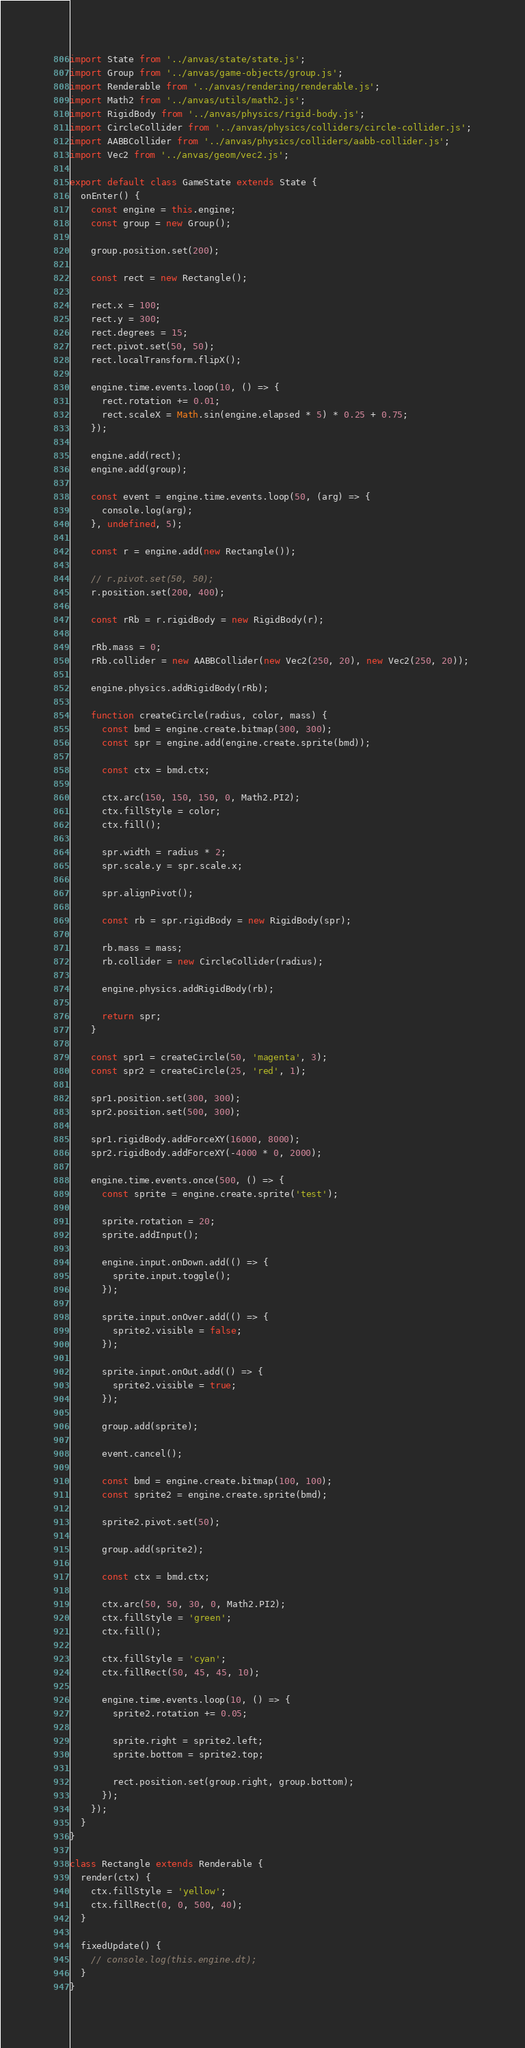<code> <loc_0><loc_0><loc_500><loc_500><_JavaScript_>import State from '../anvas/state/state.js';
import Group from '../anvas/game-objects/group.js';
import Renderable from '../anvas/rendering/renderable.js';
import Math2 from '../anvas/utils/math2.js';
import RigidBody from '../anvas/physics/rigid-body.js';
import CircleCollider from '../anvas/physics/colliders/circle-collider.js';
import AABBCollider from '../anvas/physics/colliders/aabb-collider.js';
import Vec2 from '../anvas/geom/vec2.js';

export default class GameState extends State {
  onEnter() {
    const engine = this.engine;
    const group = new Group();

    group.position.set(200);

    const rect = new Rectangle();

    rect.x = 100;
    rect.y = 300;
    rect.degrees = 15;
    rect.pivot.set(50, 50);
    rect.localTransform.flipX();

    engine.time.events.loop(10, () => {
      rect.rotation += 0.01;
      rect.scaleX = Math.sin(engine.elapsed * 5) * 0.25 + 0.75;
    });

    engine.add(rect);
    engine.add(group);

    const event = engine.time.events.loop(50, (arg) => {
      console.log(arg);
    }, undefined, 5);

    const r = engine.add(new Rectangle());

    // r.pivot.set(50, 50);
    r.position.set(200, 400);

    const rRb = r.rigidBody = new RigidBody(r);

    rRb.mass = 0;
    rRb.collider = new AABBCollider(new Vec2(250, 20), new Vec2(250, 20));

    engine.physics.addRigidBody(rRb);

    function createCircle(radius, color, mass) {
      const bmd = engine.create.bitmap(300, 300);
      const spr = engine.add(engine.create.sprite(bmd));

      const ctx = bmd.ctx;

      ctx.arc(150, 150, 150, 0, Math2.PI2);
      ctx.fillStyle = color;
      ctx.fill();

      spr.width = radius * 2;
      spr.scale.y = spr.scale.x;

      spr.alignPivot();

      const rb = spr.rigidBody = new RigidBody(spr);

      rb.mass = mass;
      rb.collider = new CircleCollider(radius);

      engine.physics.addRigidBody(rb);

      return spr;
    }

    const spr1 = createCircle(50, 'magenta', 3);
    const spr2 = createCircle(25, 'red', 1);

    spr1.position.set(300, 300);
    spr2.position.set(500, 300);

    spr1.rigidBody.addForceXY(16000, 8000);
    spr2.rigidBody.addForceXY(-4000 * 0, 2000);

    engine.time.events.once(500, () => {
      const sprite = engine.create.sprite('test');

      sprite.rotation = 20;
      sprite.addInput();

      engine.input.onDown.add(() => {
        sprite.input.toggle();
      });

      sprite.input.onOver.add(() => {
        sprite2.visible = false;    
      });

      sprite.input.onOut.add(() => {
        sprite2.visible = true;    
      });

      group.add(sprite);

      event.cancel();

      const bmd = engine.create.bitmap(100, 100);
      const sprite2 = engine.create.sprite(bmd);

      sprite2.pivot.set(50);

      group.add(sprite2);

      const ctx = bmd.ctx;

      ctx.arc(50, 50, 30, 0, Math2.PI2);
      ctx.fillStyle = 'green';
      ctx.fill();

      ctx.fillStyle = 'cyan';
      ctx.fillRect(50, 45, 45, 10);

      engine.time.events.loop(10, () => {
        sprite2.rotation += 0.05;

        sprite.right = sprite2.left;
        sprite.bottom = sprite2.top;

        rect.position.set(group.right, group.bottom);
      });
    });
  }
}

class Rectangle extends Renderable {
  render(ctx) {
    ctx.fillStyle = 'yellow';
    ctx.fillRect(0, 0, 500, 40);
  }

  fixedUpdate() {
    // console.log(this.engine.dt);
  }
}
</code> 